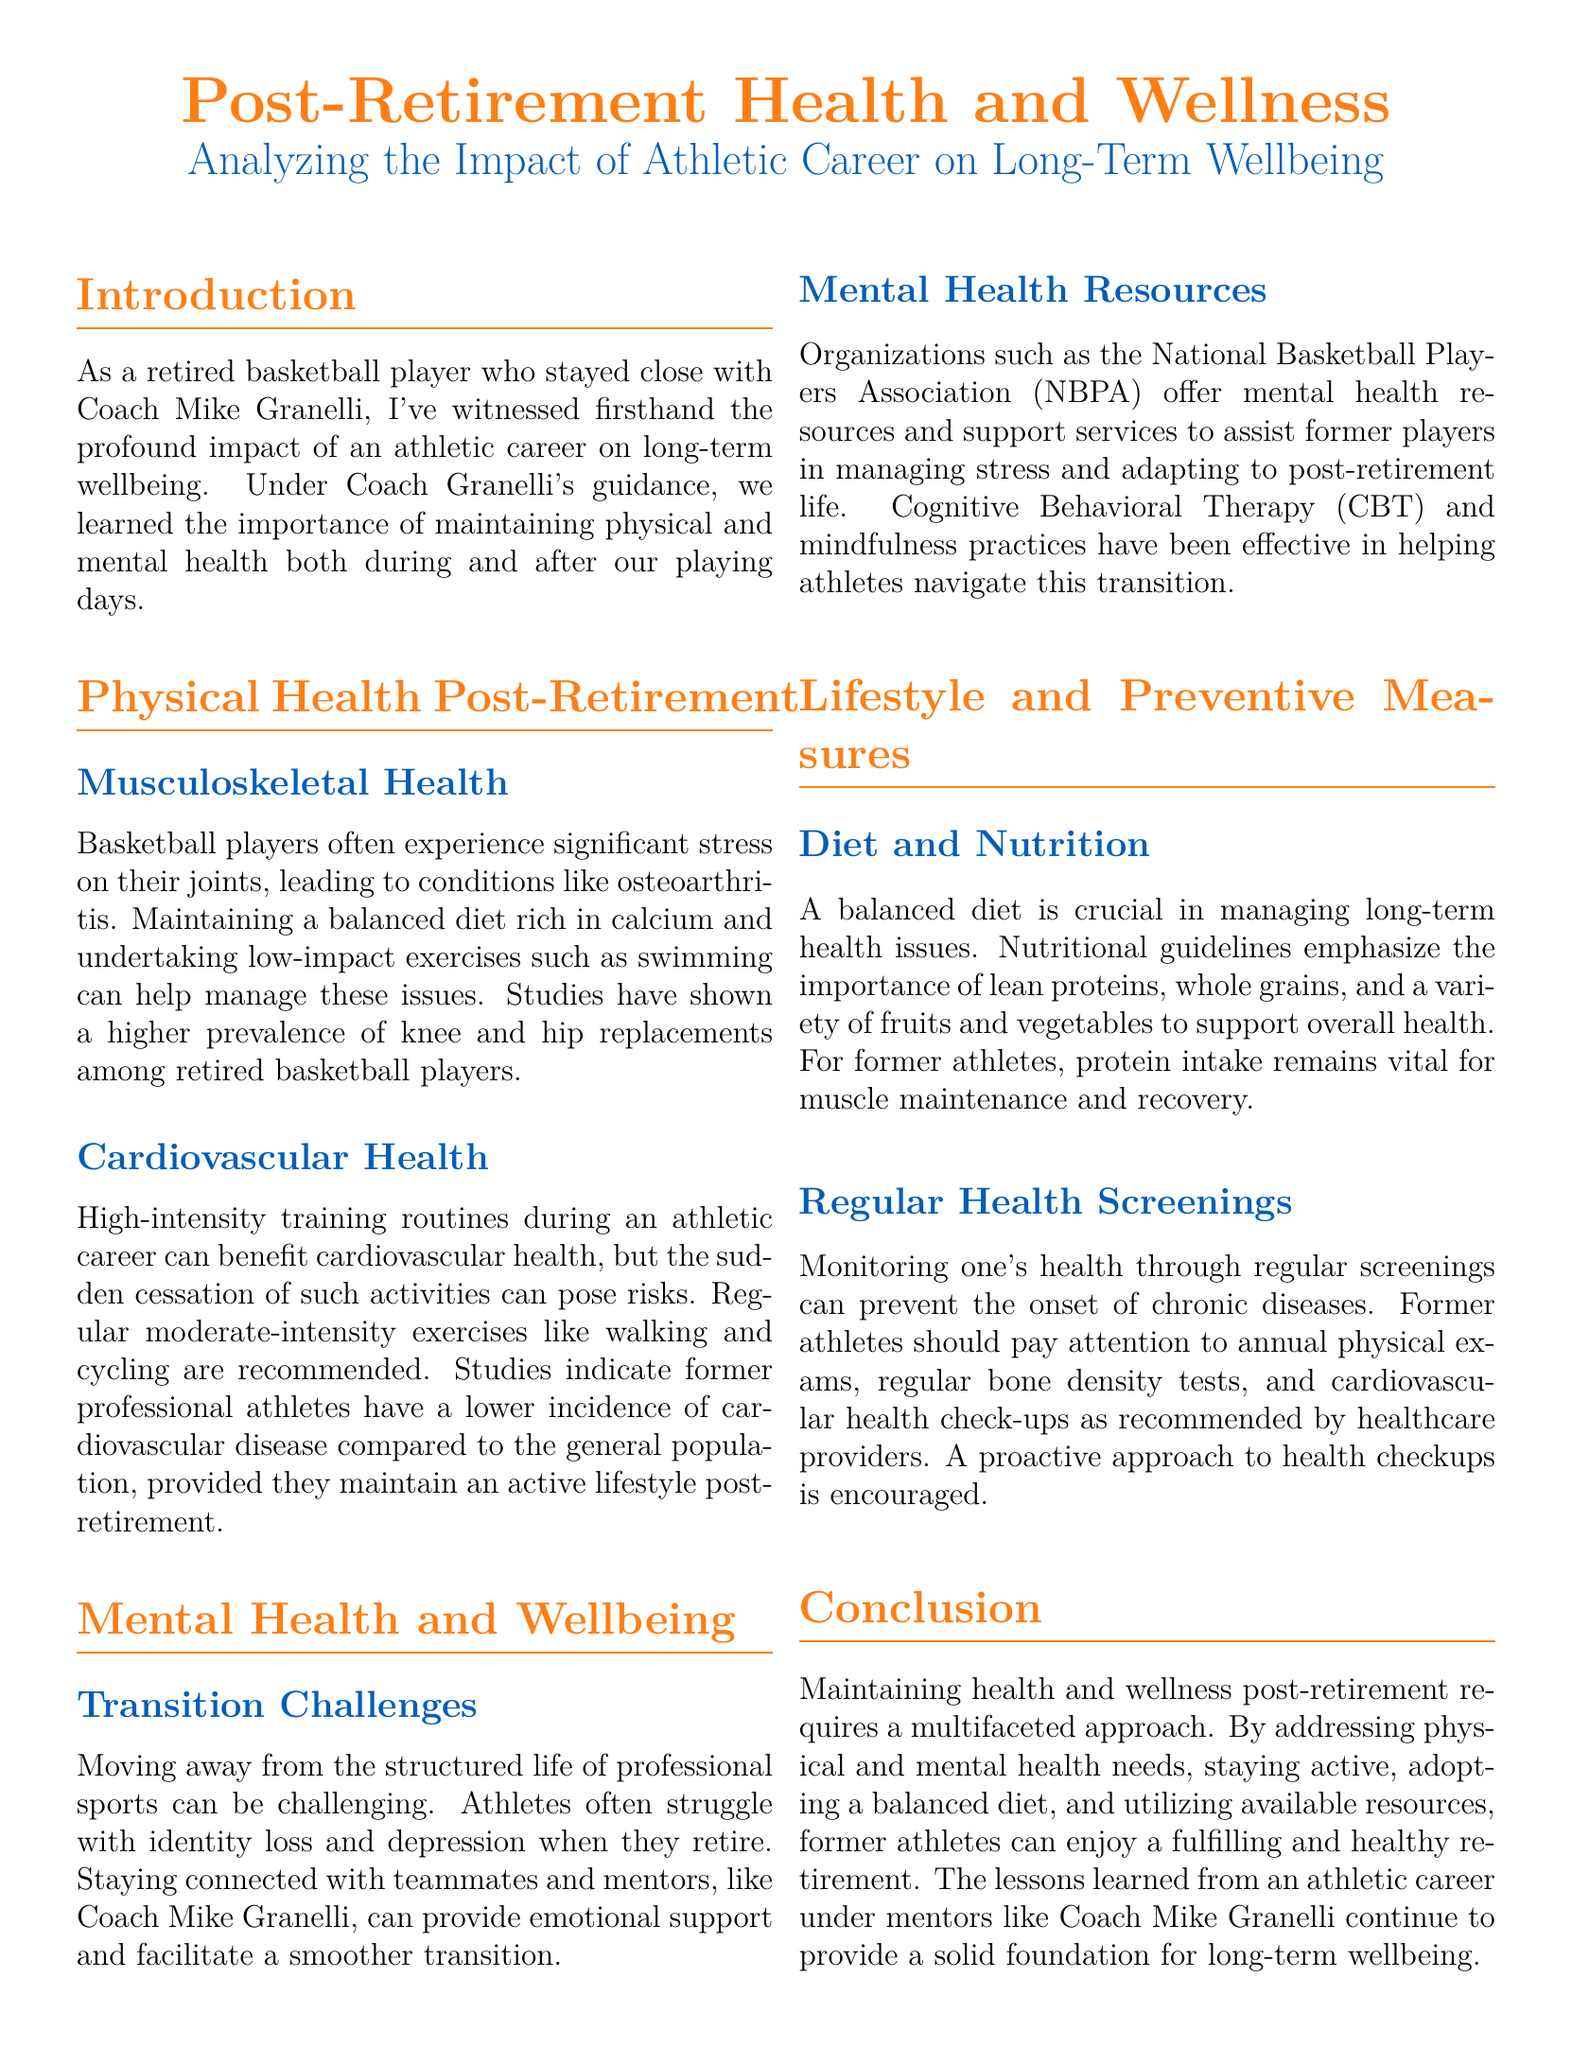What condition do retired basketball players often face regarding their joints? The document mentions osteoarthritis as a significant condition faced by retired basketball players due to stress on their joints.
Answer: osteoarthritis What type of exercises are recommended for cardiovascular health post-retirement? The text suggests regular moderate-intensity exercises such as walking and cycling to maintain cardiovascular health after retirement.
Answer: walking and cycling Which organization offers mental health resources to former basketball players? The National Basketball Players Association (NBPA) is identified in the document as providing mental health resources and support services to assist former players.
Answer: National Basketball Players Association (NBPA) What is emphasized as important for a balanced diet in the document? The document underscores the importance of lean proteins, whole grains, and a variety of fruits and vegetables in a balanced diet for overall health management.
Answer: lean proteins, whole grains, and a variety of fruits and vegetables What therapy is mentioned as effective for helping athletes navigate their transition post-retirement? The document states that Cognitive Behavioral Therapy (CBT) has been effective in assisting athletes with their transition challenges after retirement.
Answer: Cognitive Behavioral Therapy (CBT) What issue do many athletes face when moving away from professional sports? The text highlights identity loss as one of the significant challenges retired athletes encounter when they transition away from professional sports.
Answer: identity loss How can former athletes maintain muscle maintenance according to the document? The document indicates that protein intake remains vital for muscle maintenance and recovery for former athletes.
Answer: protein intake What is recommended for monitoring health post-retirement? The document recommends conducting regular health screenings, including annual physical exams and cardiovascular health check-ups, to monitor health after retirement.
Answer: regular health screenings 